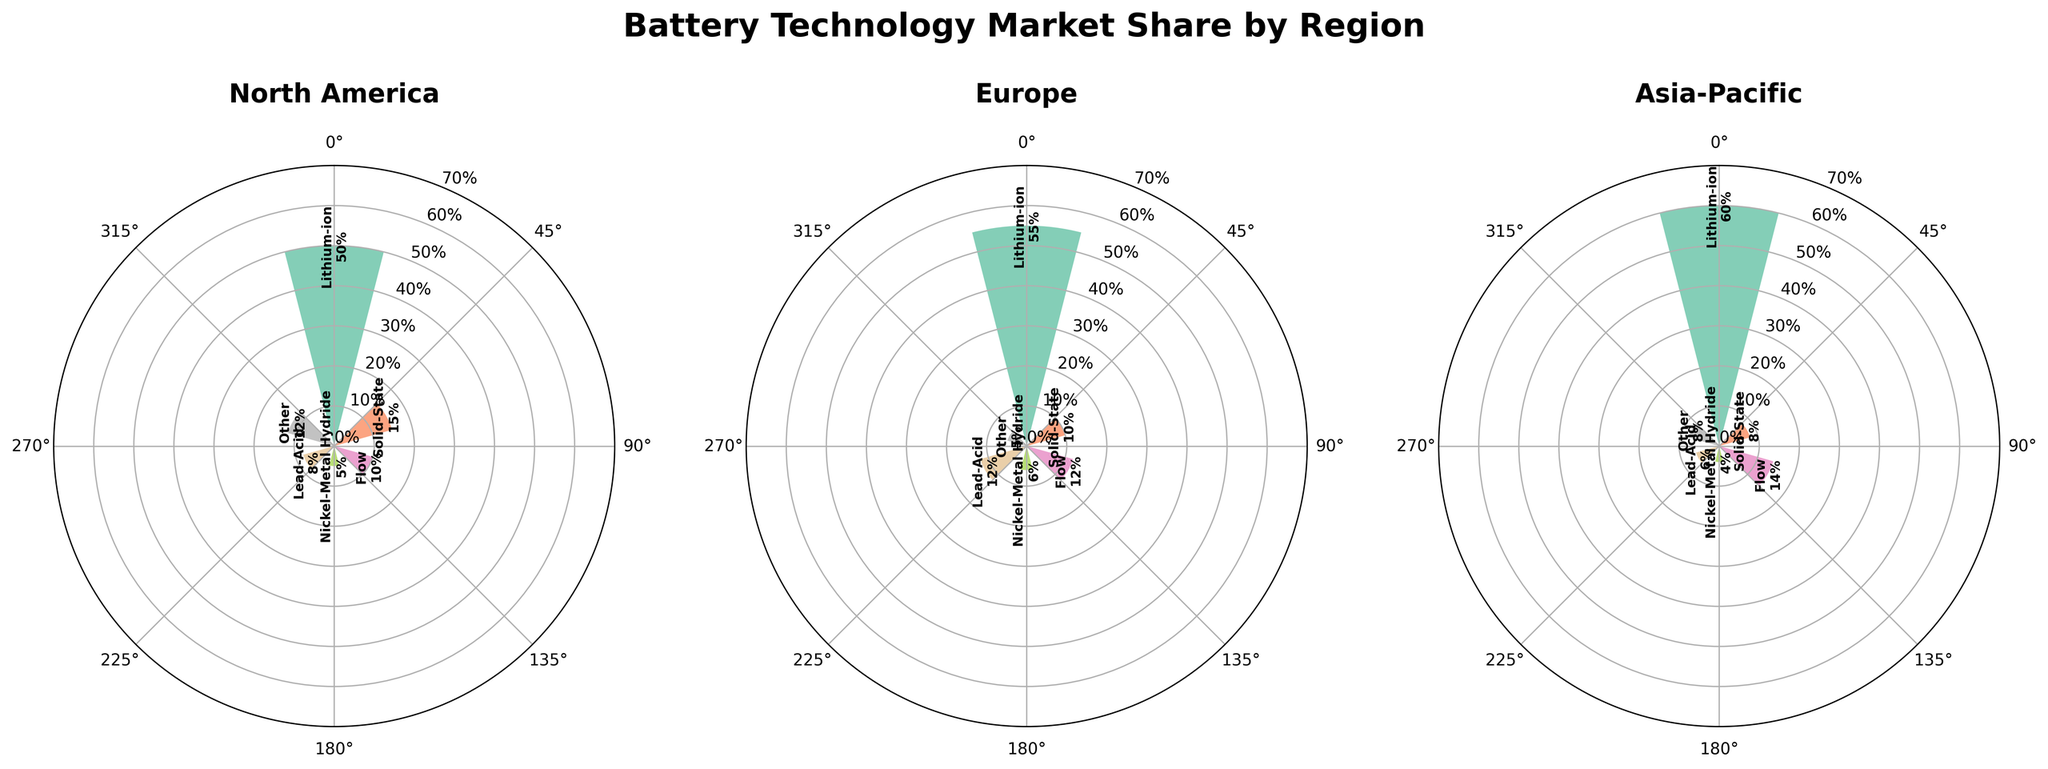What type of battery technology has the highest market share in North America? The tallest bar in the North America subplot corresponds to lithium-ion batteries, indicating they have the highest market share.
Answer: Lithium-ion What is the total market share of solid-state batteries across all regions? Sum the market share percentages for solid-state batteries in North America (15%), Europe (10%), and Asia-Pacific (8%). 15% + 10% + 8% = 33%.
Answer: 33% Which region has the smallest market share for flow batteries? The Asia-Pacific region has the shortest bar for flow batteries at 8% market share, compared to other regions.
Answer: Asia-Pacific How much higher is the market share of lithium-ion batteries in Asia-Pacific compared to North America? Lithium-ion batteries have a market share of 60% in Asia-Pacific and 50% in North America. The difference is 60% - 50% = 10%.
Answer: 10% In Europe, which battery technology has the same market share as lead-acid batteries? Both lead-acid and flow batteries share the same market share percentage of 12% in Europe, as indicated by bars of the same height.
Answer: Flow What is the average market share of lithium-ion batteries across all regions? Calculate the average by summing the market share percentages for lithium-ion batteries in North America (50%), Europe (55%), and Asia-Pacific (60%) and then dividing by the number of regions (3). (50% + 55% + 60%) / 3 = 55%.
Answer: 55% For which battery technology does North America have a higher market share than Europe? North America has a higher market share than Europe for solid-state (15% vs 10%), flow (10% vs 12%), nickel-metal hydride (5% vs 6%), and lead-acid (8% vs 12%), but the final answer is lithium-ion where North America's 50% is less than Europe's 55%. Hence, "solid-state".
Answer: Solid-State What is the combined market share of "Other" battery technologies in North America and Asia-Pacific? Sum the market share percentages for "Other" batteries in North America (12%) and Asia-Pacific (8%). 12% + 8% = 20%.
Answer: 20% Which region appears to have the most balanced distribution of market share percentages across different battery technologies? By observing the length of bars, Europe has relatively balanced heights compared to North America and Asia-Pacific, where certain technologies dominate heavily.
Answer: Europe Describe the overall trend of market share for lithium-ion batteries across the three regions. The market share for lithium-ion batteries gradually increases, starting from North America (50%), moving to Europe (55%), and reaching the highest in Asia-Pacific (60%). This suggests a growing dominance of lithium-ion batteries from West to East.
Answer: Increasing from North America to Asia-Pacific 